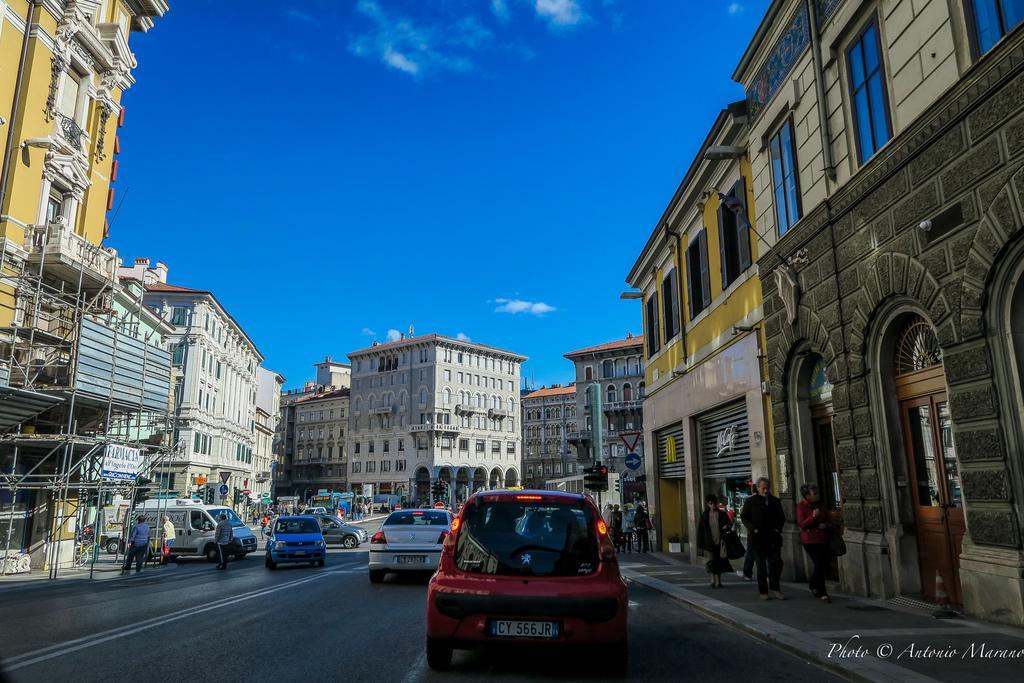In one or two sentences, can you explain what this image depicts? In the picture we can see a road on it, we can see some vehicles are coming and going and besides it, we can see some people are walking on the path near the building and background is covered with buildings and windows in it and on the top of it we can see a sky with clouds. 